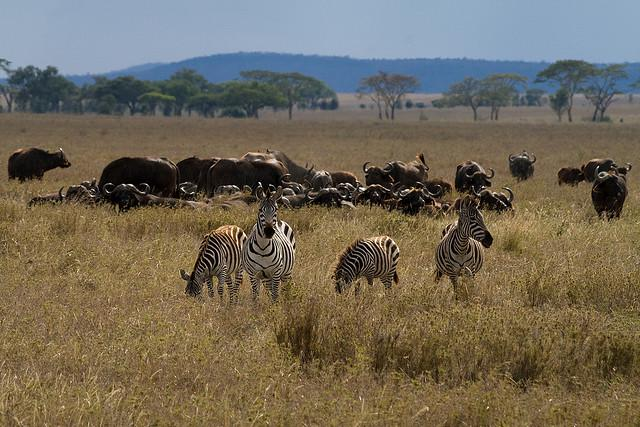How many zebras are standing in front of the pack of buffalo? Please explain your reasoning. four. There are 4. 